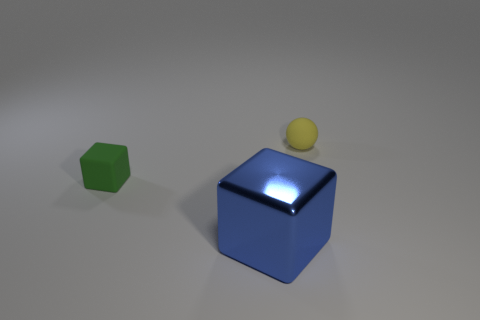Add 3 small yellow matte balls. How many objects exist? 6 Subtract all blocks. How many objects are left? 1 Add 2 large blue shiny objects. How many large blue shiny objects exist? 3 Subtract 0 yellow cylinders. How many objects are left? 3 Subtract all yellow objects. Subtract all big blue blocks. How many objects are left? 1 Add 3 small yellow matte spheres. How many small yellow matte spheres are left? 4 